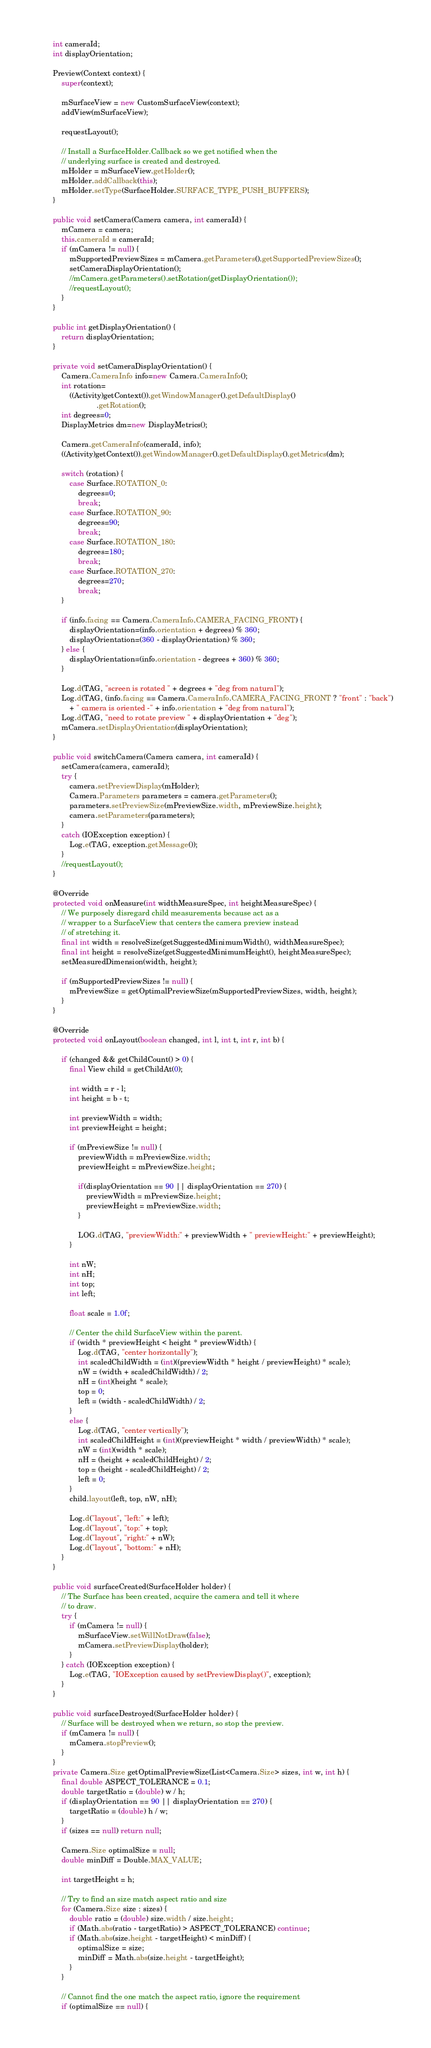Convert code to text. <code><loc_0><loc_0><loc_500><loc_500><_Java_>    int cameraId;
    int displayOrientation;

    Preview(Context context) {
        super(context);

        mSurfaceView = new CustomSurfaceView(context);
        addView(mSurfaceView);

        requestLayout();

        // Install a SurfaceHolder.Callback so we get notified when the
        // underlying surface is created and destroyed.
        mHolder = mSurfaceView.getHolder();
        mHolder.addCallback(this);
        mHolder.setType(SurfaceHolder.SURFACE_TYPE_PUSH_BUFFERS);
    }

    public void setCamera(Camera camera, int cameraId) {
        mCamera = camera;
        this.cameraId = cameraId;
        if (mCamera != null) {
            mSupportedPreviewSizes = mCamera.getParameters().getSupportedPreviewSizes();
            setCameraDisplayOrientation();
            //mCamera.getParameters().setRotation(getDisplayOrientation());
            //requestLayout();
        }
    }

    public int getDisplayOrientation() {
    	return displayOrientation;
    }

    private void setCameraDisplayOrientation() {
        Camera.CameraInfo info=new Camera.CameraInfo();
        int rotation=
            ((Activity)getContext()).getWindowManager().getDefaultDisplay()
                         .getRotation();
        int degrees=0;
        DisplayMetrics dm=new DisplayMetrics();

        Camera.getCameraInfo(cameraId, info);
        ((Activity)getContext()).getWindowManager().getDefaultDisplay().getMetrics(dm);

        switch (rotation) {
            case Surface.ROTATION_0:
                degrees=0;
                break;
            case Surface.ROTATION_90:
                degrees=90;
                break;
            case Surface.ROTATION_180:
                degrees=180;
                break;
            case Surface.ROTATION_270:
                degrees=270;
                break;
        }

        if (info.facing == Camera.CameraInfo.CAMERA_FACING_FRONT) {
        	displayOrientation=(info.orientation + degrees) % 360;
        	displayOrientation=(360 - displayOrientation) % 360;
        } else {
        	displayOrientation=(info.orientation - degrees + 360) % 360;
        }

        Log.d(TAG, "screen is rotated " + degrees + "deg from natural");
        Log.d(TAG, (info.facing == Camera.CameraInfo.CAMERA_FACING_FRONT ? "front" : "back")
        	+ " camera is oriented -" + info.orientation + "deg from natural");
        Log.d(TAG, "need to rotate preview " + displayOrientation + "deg");
        mCamera.setDisplayOrientation(displayOrientation);
    }

    public void switchCamera(Camera camera, int cameraId) {
        setCamera(camera, cameraId);
        try {
            camera.setPreviewDisplay(mHolder);
	        Camera.Parameters parameters = camera.getParameters();
            parameters.setPreviewSize(mPreviewSize.width, mPreviewSize.height);
	        camera.setParameters(parameters);
        }
        catch (IOException exception) {
            Log.e(TAG, exception.getMessage());
        }
        //requestLayout();
    }

    @Override
    protected void onMeasure(int widthMeasureSpec, int heightMeasureSpec) {
        // We purposely disregard child measurements because act as a
        // wrapper to a SurfaceView that centers the camera preview instead
        // of stretching it.
        final int width = resolveSize(getSuggestedMinimumWidth(), widthMeasureSpec);
        final int height = resolveSize(getSuggestedMinimumHeight(), heightMeasureSpec);
        setMeasuredDimension(width, height);

        if (mSupportedPreviewSizes != null) {
            mPreviewSize = getOptimalPreviewSize(mSupportedPreviewSizes, width, height);
        }
    }

    @Override
    protected void onLayout(boolean changed, int l, int t, int r, int b) {

        if (changed && getChildCount() > 0) {
            final View child = getChildAt(0);

            int width = r - l;
            int height = b - t;

            int previewWidth = width;
            int previewHeight = height;

            if (mPreviewSize != null) {
                previewWidth = mPreviewSize.width;
                previewHeight = mPreviewSize.height;

                if(displayOrientation == 90 || displayOrientation == 270) {
                    previewWidth = mPreviewSize.height;
                    previewHeight = mPreviewSize.width;
                }

	            LOG.d(TAG, "previewWidth:" + previewWidth + " previewHeight:" + previewHeight);
            }

            int nW;
            int nH;
            int top;
            int left;

            float scale = 1.0f;

            // Center the child SurfaceView within the parent.
            if (width * previewHeight < height * previewWidth) {
                Log.d(TAG, "center horizontally");
                int scaledChildWidth = (int)((previewWidth * height / previewHeight) * scale);
                nW = (width + scaledChildWidth) / 2;
                nH = (int)(height * scale);
                top = 0;
                left = (width - scaledChildWidth) / 2;
            }
            else {
                Log.d(TAG, "center vertically");
                int scaledChildHeight = (int)((previewHeight * width / previewWidth) * scale);
                nW = (int)(width * scale);
                nH = (height + scaledChildHeight) / 2;
                top = (height - scaledChildHeight) / 2;
                left = 0;
            }
            child.layout(left, top, nW, nH);

            Log.d("layout", "left:" + left);
            Log.d("layout", "top:" + top);
            Log.d("layout", "right:" + nW);
            Log.d("layout", "bottom:" + nH);
        }
    }

    public void surfaceCreated(SurfaceHolder holder) {
        // The Surface has been created, acquire the camera and tell it where
        // to draw.
        try {
            if (mCamera != null) {
                mSurfaceView.setWillNotDraw(false);
                mCamera.setPreviewDisplay(holder);
            }
        } catch (IOException exception) {
            Log.e(TAG, "IOException caused by setPreviewDisplay()", exception);
        }
    }

    public void surfaceDestroyed(SurfaceHolder holder) {
        // Surface will be destroyed when we return, so stop the preview.
        if (mCamera != null) {
            mCamera.stopPreview();
        }
    }
    private Camera.Size getOptimalPreviewSize(List<Camera.Size> sizes, int w, int h) {
        final double ASPECT_TOLERANCE = 0.1;
        double targetRatio = (double) w / h;
        if (displayOrientation == 90 || displayOrientation == 270) {
            targetRatio = (double) h / w;
        }
        if (sizes == null) return null;

        Camera.Size optimalSize = null;
        double minDiff = Double.MAX_VALUE;

        int targetHeight = h;

        // Try to find an size match aspect ratio and size
        for (Camera.Size size : sizes) {
            double ratio = (double) size.width / size.height;
            if (Math.abs(ratio - targetRatio) > ASPECT_TOLERANCE) continue;
            if (Math.abs(size.height - targetHeight) < minDiff) {
                optimalSize = size;
                minDiff = Math.abs(size.height - targetHeight);
            }
        }

        // Cannot find the one match the aspect ratio, ignore the requirement
        if (optimalSize == null) {</code> 